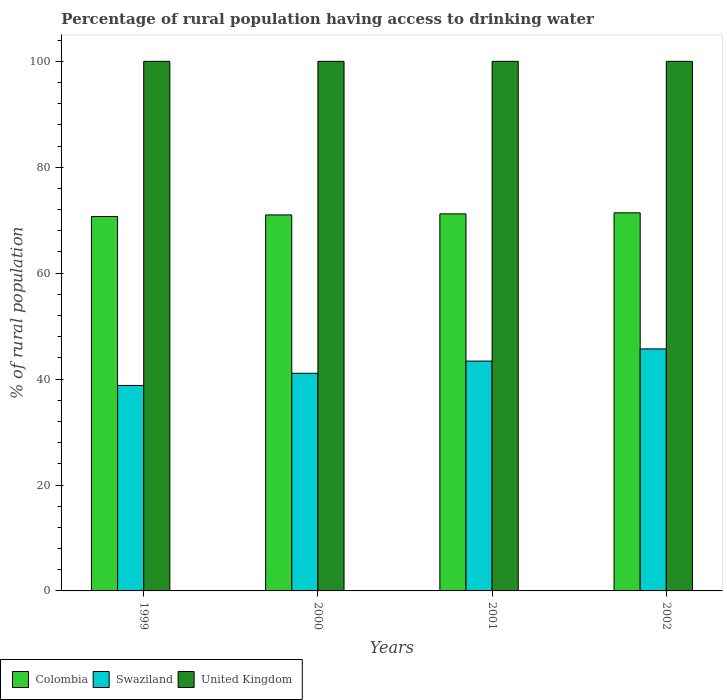How many groups of bars are there?
Your response must be concise. 4. In how many cases, is the number of bars for a given year not equal to the number of legend labels?
Your response must be concise. 0. What is the percentage of rural population having access to drinking water in Colombia in 2001?
Offer a terse response. 71.2. Across all years, what is the maximum percentage of rural population having access to drinking water in United Kingdom?
Your response must be concise. 100. Across all years, what is the minimum percentage of rural population having access to drinking water in Colombia?
Offer a very short reply. 70.7. In which year was the percentage of rural population having access to drinking water in Swaziland maximum?
Offer a very short reply. 2002. What is the total percentage of rural population having access to drinking water in United Kingdom in the graph?
Offer a very short reply. 400. What is the difference between the percentage of rural population having access to drinking water in United Kingdom in 1999 and that in 2001?
Your answer should be very brief. 0. What is the difference between the percentage of rural population having access to drinking water in Swaziland in 2002 and the percentage of rural population having access to drinking water in Colombia in 1999?
Offer a terse response. -25. In the year 2001, what is the difference between the percentage of rural population having access to drinking water in United Kingdom and percentage of rural population having access to drinking water in Swaziland?
Your response must be concise. 56.6. What is the ratio of the percentage of rural population having access to drinking water in Colombia in 2000 to that in 2001?
Your answer should be very brief. 1. What is the difference between the highest and the second highest percentage of rural population having access to drinking water in Colombia?
Offer a very short reply. 0.2. What is the difference between the highest and the lowest percentage of rural population having access to drinking water in Colombia?
Give a very brief answer. 0.7. In how many years, is the percentage of rural population having access to drinking water in Colombia greater than the average percentage of rural population having access to drinking water in Colombia taken over all years?
Your answer should be compact. 2. What does the 2nd bar from the left in 2001 represents?
Offer a very short reply. Swaziland. Is it the case that in every year, the sum of the percentage of rural population having access to drinking water in Colombia and percentage of rural population having access to drinking water in Swaziland is greater than the percentage of rural population having access to drinking water in United Kingdom?
Your answer should be compact. Yes. How many bars are there?
Your response must be concise. 12. Are all the bars in the graph horizontal?
Offer a terse response. No. What is the difference between two consecutive major ticks on the Y-axis?
Give a very brief answer. 20. Does the graph contain any zero values?
Give a very brief answer. No. Does the graph contain grids?
Keep it short and to the point. No. How are the legend labels stacked?
Provide a short and direct response. Horizontal. What is the title of the graph?
Give a very brief answer. Percentage of rural population having access to drinking water. Does "Dominica" appear as one of the legend labels in the graph?
Keep it short and to the point. No. What is the label or title of the X-axis?
Offer a terse response. Years. What is the label or title of the Y-axis?
Ensure brevity in your answer.  % of rural population. What is the % of rural population in Colombia in 1999?
Provide a short and direct response. 70.7. What is the % of rural population of Swaziland in 1999?
Offer a terse response. 38.8. What is the % of rural population in United Kingdom in 1999?
Make the answer very short. 100. What is the % of rural population in Colombia in 2000?
Make the answer very short. 71. What is the % of rural population of Swaziland in 2000?
Give a very brief answer. 41.1. What is the % of rural population of United Kingdom in 2000?
Offer a very short reply. 100. What is the % of rural population in Colombia in 2001?
Keep it short and to the point. 71.2. What is the % of rural population of Swaziland in 2001?
Offer a very short reply. 43.4. What is the % of rural population in Colombia in 2002?
Offer a terse response. 71.4. What is the % of rural population of Swaziland in 2002?
Provide a succinct answer. 45.7. What is the % of rural population in United Kingdom in 2002?
Keep it short and to the point. 100. Across all years, what is the maximum % of rural population of Colombia?
Your answer should be compact. 71.4. Across all years, what is the maximum % of rural population of Swaziland?
Your answer should be compact. 45.7. Across all years, what is the maximum % of rural population in United Kingdom?
Provide a short and direct response. 100. Across all years, what is the minimum % of rural population of Colombia?
Your response must be concise. 70.7. Across all years, what is the minimum % of rural population in Swaziland?
Provide a short and direct response. 38.8. What is the total % of rural population in Colombia in the graph?
Ensure brevity in your answer.  284.3. What is the total % of rural population of Swaziland in the graph?
Make the answer very short. 169. What is the total % of rural population in United Kingdom in the graph?
Provide a succinct answer. 400. What is the difference between the % of rural population in Colombia in 1999 and that in 2000?
Offer a very short reply. -0.3. What is the difference between the % of rural population of Swaziland in 1999 and that in 2000?
Keep it short and to the point. -2.3. What is the difference between the % of rural population of United Kingdom in 1999 and that in 2000?
Offer a terse response. 0. What is the difference between the % of rural population of Colombia in 1999 and that in 2001?
Provide a short and direct response. -0.5. What is the difference between the % of rural population in Swaziland in 1999 and that in 2001?
Make the answer very short. -4.6. What is the difference between the % of rural population of Colombia in 1999 and that in 2002?
Give a very brief answer. -0.7. What is the difference between the % of rural population in Swaziland in 1999 and that in 2002?
Offer a very short reply. -6.9. What is the difference between the % of rural population in United Kingdom in 1999 and that in 2002?
Your answer should be very brief. 0. What is the difference between the % of rural population of Colombia in 2000 and that in 2001?
Your response must be concise. -0.2. What is the difference between the % of rural population in Swaziland in 2000 and that in 2001?
Ensure brevity in your answer.  -2.3. What is the difference between the % of rural population in United Kingdom in 2000 and that in 2002?
Offer a terse response. 0. What is the difference between the % of rural population in Colombia in 2001 and that in 2002?
Your answer should be compact. -0.2. What is the difference between the % of rural population in Colombia in 1999 and the % of rural population in Swaziland in 2000?
Your response must be concise. 29.6. What is the difference between the % of rural population of Colombia in 1999 and the % of rural population of United Kingdom in 2000?
Your answer should be compact. -29.3. What is the difference between the % of rural population in Swaziland in 1999 and the % of rural population in United Kingdom in 2000?
Give a very brief answer. -61.2. What is the difference between the % of rural population in Colombia in 1999 and the % of rural population in Swaziland in 2001?
Your answer should be compact. 27.3. What is the difference between the % of rural population in Colombia in 1999 and the % of rural population in United Kingdom in 2001?
Your answer should be very brief. -29.3. What is the difference between the % of rural population of Swaziland in 1999 and the % of rural population of United Kingdom in 2001?
Keep it short and to the point. -61.2. What is the difference between the % of rural population in Colombia in 1999 and the % of rural population in United Kingdom in 2002?
Offer a terse response. -29.3. What is the difference between the % of rural population in Swaziland in 1999 and the % of rural population in United Kingdom in 2002?
Keep it short and to the point. -61.2. What is the difference between the % of rural population of Colombia in 2000 and the % of rural population of Swaziland in 2001?
Your answer should be compact. 27.6. What is the difference between the % of rural population in Swaziland in 2000 and the % of rural population in United Kingdom in 2001?
Offer a very short reply. -58.9. What is the difference between the % of rural population in Colombia in 2000 and the % of rural population in Swaziland in 2002?
Offer a very short reply. 25.3. What is the difference between the % of rural population in Swaziland in 2000 and the % of rural population in United Kingdom in 2002?
Ensure brevity in your answer.  -58.9. What is the difference between the % of rural population of Colombia in 2001 and the % of rural population of Swaziland in 2002?
Provide a short and direct response. 25.5. What is the difference between the % of rural population in Colombia in 2001 and the % of rural population in United Kingdom in 2002?
Provide a succinct answer. -28.8. What is the difference between the % of rural population in Swaziland in 2001 and the % of rural population in United Kingdom in 2002?
Make the answer very short. -56.6. What is the average % of rural population of Colombia per year?
Make the answer very short. 71.08. What is the average % of rural population in Swaziland per year?
Your answer should be very brief. 42.25. In the year 1999, what is the difference between the % of rural population of Colombia and % of rural population of Swaziland?
Your answer should be compact. 31.9. In the year 1999, what is the difference between the % of rural population of Colombia and % of rural population of United Kingdom?
Ensure brevity in your answer.  -29.3. In the year 1999, what is the difference between the % of rural population of Swaziland and % of rural population of United Kingdom?
Keep it short and to the point. -61.2. In the year 2000, what is the difference between the % of rural population in Colombia and % of rural population in Swaziland?
Offer a very short reply. 29.9. In the year 2000, what is the difference between the % of rural population in Swaziland and % of rural population in United Kingdom?
Your response must be concise. -58.9. In the year 2001, what is the difference between the % of rural population of Colombia and % of rural population of Swaziland?
Provide a short and direct response. 27.8. In the year 2001, what is the difference between the % of rural population of Colombia and % of rural population of United Kingdom?
Ensure brevity in your answer.  -28.8. In the year 2001, what is the difference between the % of rural population in Swaziland and % of rural population in United Kingdom?
Offer a terse response. -56.6. In the year 2002, what is the difference between the % of rural population in Colombia and % of rural population in Swaziland?
Offer a very short reply. 25.7. In the year 2002, what is the difference between the % of rural population in Colombia and % of rural population in United Kingdom?
Provide a succinct answer. -28.6. In the year 2002, what is the difference between the % of rural population in Swaziland and % of rural population in United Kingdom?
Ensure brevity in your answer.  -54.3. What is the ratio of the % of rural population of Swaziland in 1999 to that in 2000?
Ensure brevity in your answer.  0.94. What is the ratio of the % of rural population of Swaziland in 1999 to that in 2001?
Your answer should be compact. 0.89. What is the ratio of the % of rural population in Colombia in 1999 to that in 2002?
Give a very brief answer. 0.99. What is the ratio of the % of rural population in Swaziland in 1999 to that in 2002?
Provide a succinct answer. 0.85. What is the ratio of the % of rural population in United Kingdom in 1999 to that in 2002?
Give a very brief answer. 1. What is the ratio of the % of rural population of Swaziland in 2000 to that in 2001?
Your answer should be compact. 0.95. What is the ratio of the % of rural population in Colombia in 2000 to that in 2002?
Offer a terse response. 0.99. What is the ratio of the % of rural population of Swaziland in 2000 to that in 2002?
Ensure brevity in your answer.  0.9. What is the ratio of the % of rural population of Colombia in 2001 to that in 2002?
Provide a succinct answer. 1. What is the ratio of the % of rural population in Swaziland in 2001 to that in 2002?
Offer a terse response. 0.95. What is the ratio of the % of rural population of United Kingdom in 2001 to that in 2002?
Ensure brevity in your answer.  1. What is the difference between the highest and the second highest % of rural population of Swaziland?
Offer a very short reply. 2.3. What is the difference between the highest and the lowest % of rural population in Swaziland?
Your response must be concise. 6.9. What is the difference between the highest and the lowest % of rural population in United Kingdom?
Offer a very short reply. 0. 